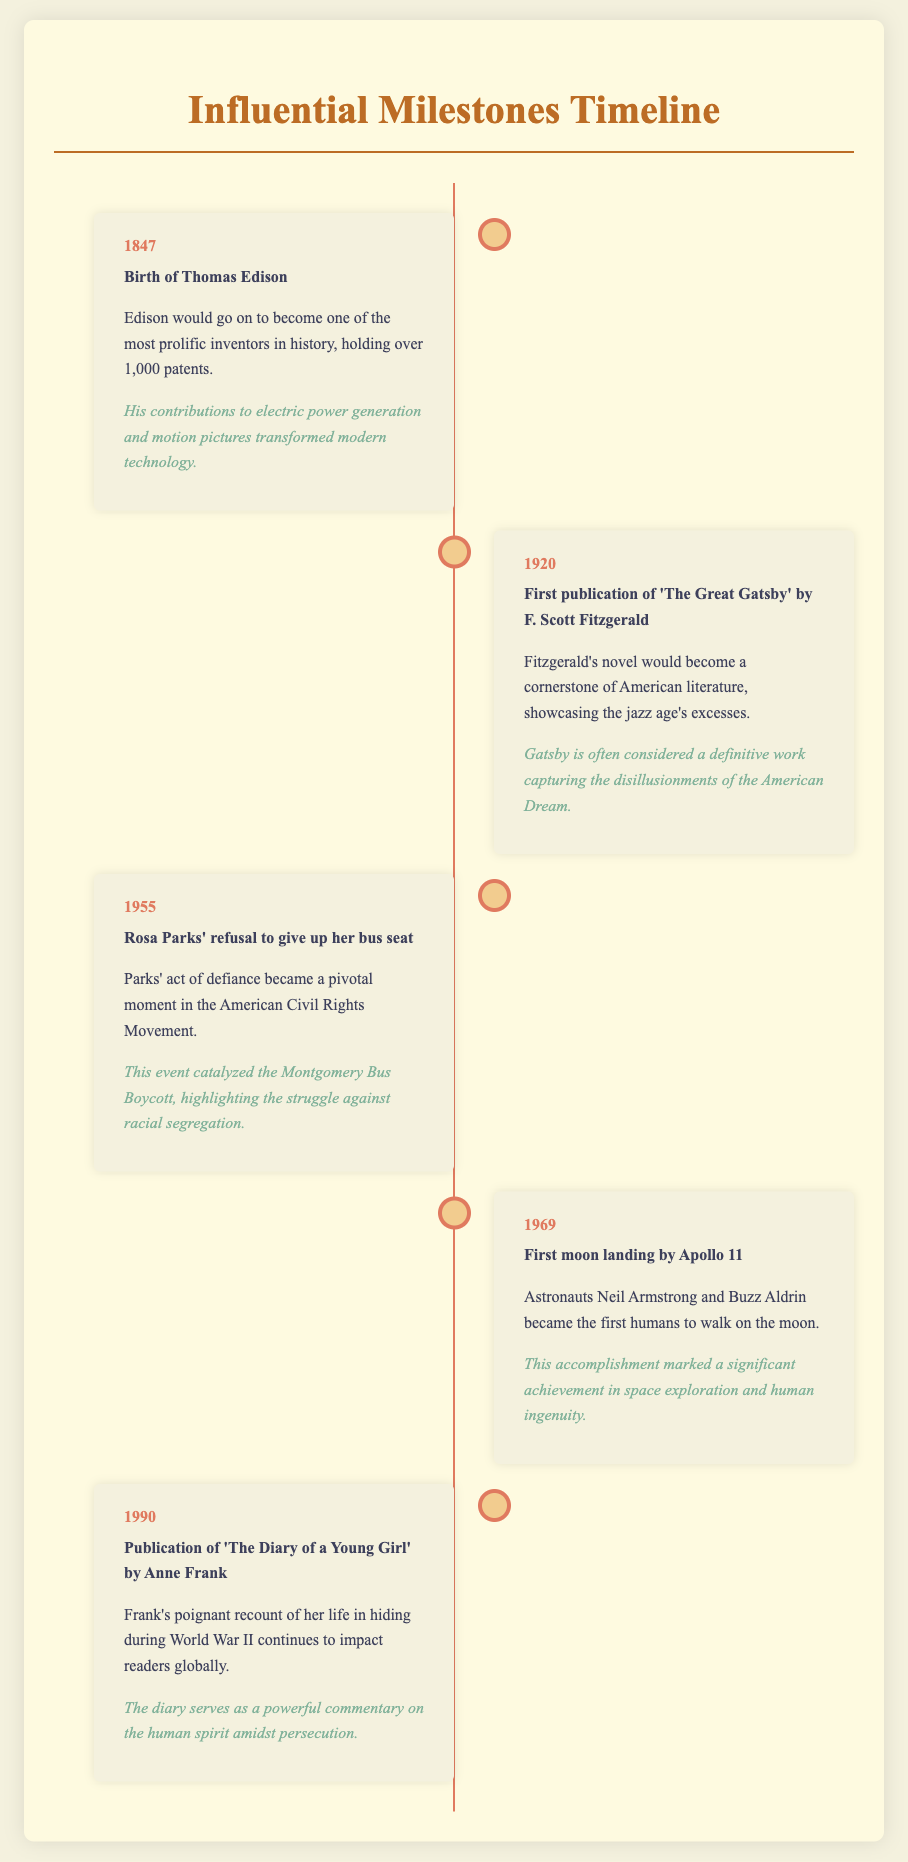What year was Thomas Edison born? The document states that Thomas Edison was born in 1847.
Answer: 1847 What notable action did Rosa Parks take in 1955? The document describes Rosa Parks' refusal to give up her bus seat as a pivotal moment.
Answer: Refusal to give up her bus seat Which novel did F. Scott Fitzgerald first publish in 1920? The document indicates that 'The Great Gatsby' was published by Fitzgerald in 1920.
Answer: 'The Great Gatsby' What significant event occurred in 1969? The Apollo 11 moon landing, with astronauts walking on the moon, is highlighted in the document for this year.
Answer: Apollo 11 moon landing Which work was published in 1990 that impacted readers globally? The document references 'The Diary of a Young Girl' by Anne Frank as published in 1990.
Answer: 'The Diary of a Young Girl' What theme does Anne Frank's diary address? The document mentions that Frank's diary serves as a commentary on the human spirit amidst persecution.
Answer: Human spirit amidst persecution How many patents did Thomas Edison hold? The document notes that Edison held over 1,000 patents.
Answer: Over 1,000 patents What does the timeline document highlight? The document provides an annotated timeline of major milestones in the lives of influential personalities.
Answer: Major milestones in the lives of influential personalities Which space exploration achievement is marked in 1969? The document specifies the first moon landing by Apollo 11 as a significant achievement.
Answer: First moon landing by Apollo 11 